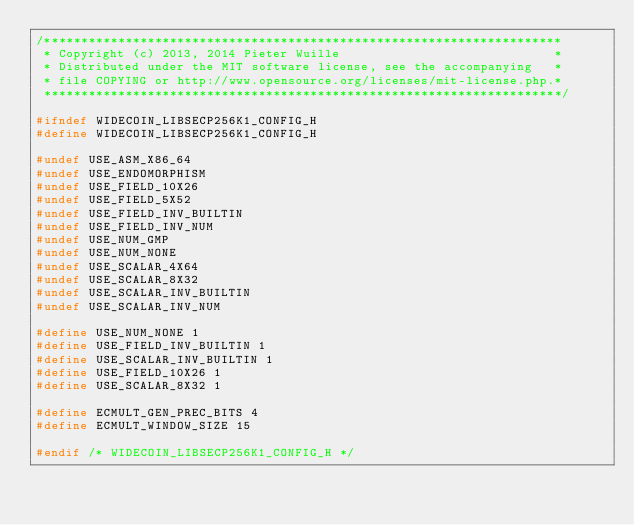Convert code to text. <code><loc_0><loc_0><loc_500><loc_500><_C_>/**********************************************************************
 * Copyright (c) 2013, 2014 Pieter Wuille                             *
 * Distributed under the MIT software license, see the accompanying   *
 * file COPYING or http://www.opensource.org/licenses/mit-license.php.*
 **********************************************************************/

#ifndef WIDECOIN_LIBSECP256K1_CONFIG_H
#define WIDECOIN_LIBSECP256K1_CONFIG_H

#undef USE_ASM_X86_64
#undef USE_ENDOMORPHISM
#undef USE_FIELD_10X26
#undef USE_FIELD_5X52
#undef USE_FIELD_INV_BUILTIN
#undef USE_FIELD_INV_NUM
#undef USE_NUM_GMP
#undef USE_NUM_NONE
#undef USE_SCALAR_4X64
#undef USE_SCALAR_8X32
#undef USE_SCALAR_INV_BUILTIN
#undef USE_SCALAR_INV_NUM

#define USE_NUM_NONE 1
#define USE_FIELD_INV_BUILTIN 1
#define USE_SCALAR_INV_BUILTIN 1
#define USE_FIELD_10X26 1
#define USE_SCALAR_8X32 1

#define ECMULT_GEN_PREC_BITS 4
#define ECMULT_WINDOW_SIZE 15

#endif /* WIDECOIN_LIBSECP256K1_CONFIG_H */
</code> 